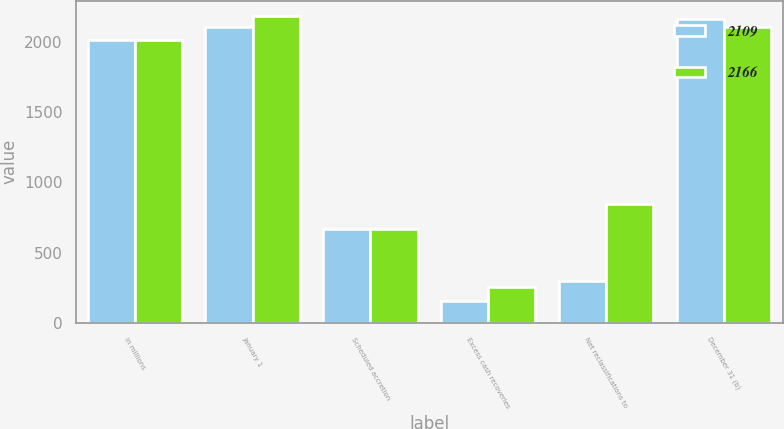<chart> <loc_0><loc_0><loc_500><loc_500><stacked_bar_chart><ecel><fcel>In millions<fcel>January 1<fcel>Scheduled accretion<fcel>Excess cash recoveries<fcel>Net reclassifications to<fcel>December 31 (b)<nl><fcel>2109<fcel>2012<fcel>2109<fcel>671<fcel>157<fcel>298<fcel>2166<nl><fcel>2166<fcel>2011<fcel>2185<fcel>666<fcel>254<fcel>844<fcel>2109<nl></chart> 